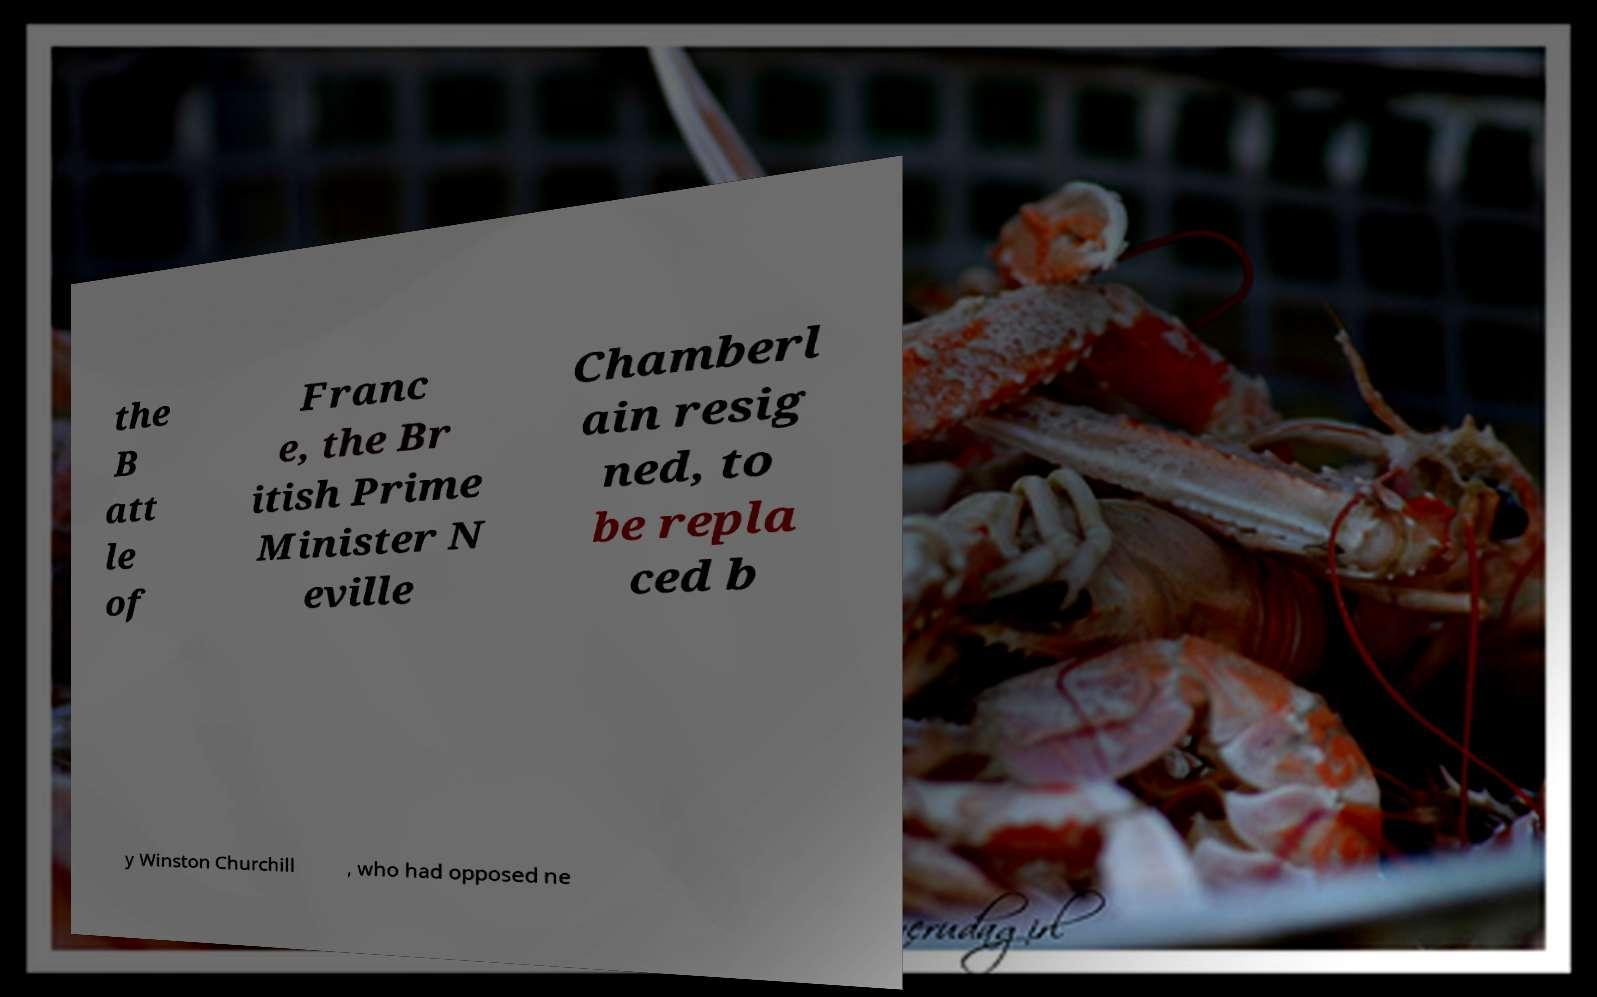What messages or text are displayed in this image? I need them in a readable, typed format. the B att le of Franc e, the Br itish Prime Minister N eville Chamberl ain resig ned, to be repla ced b y Winston Churchill , who had opposed ne 